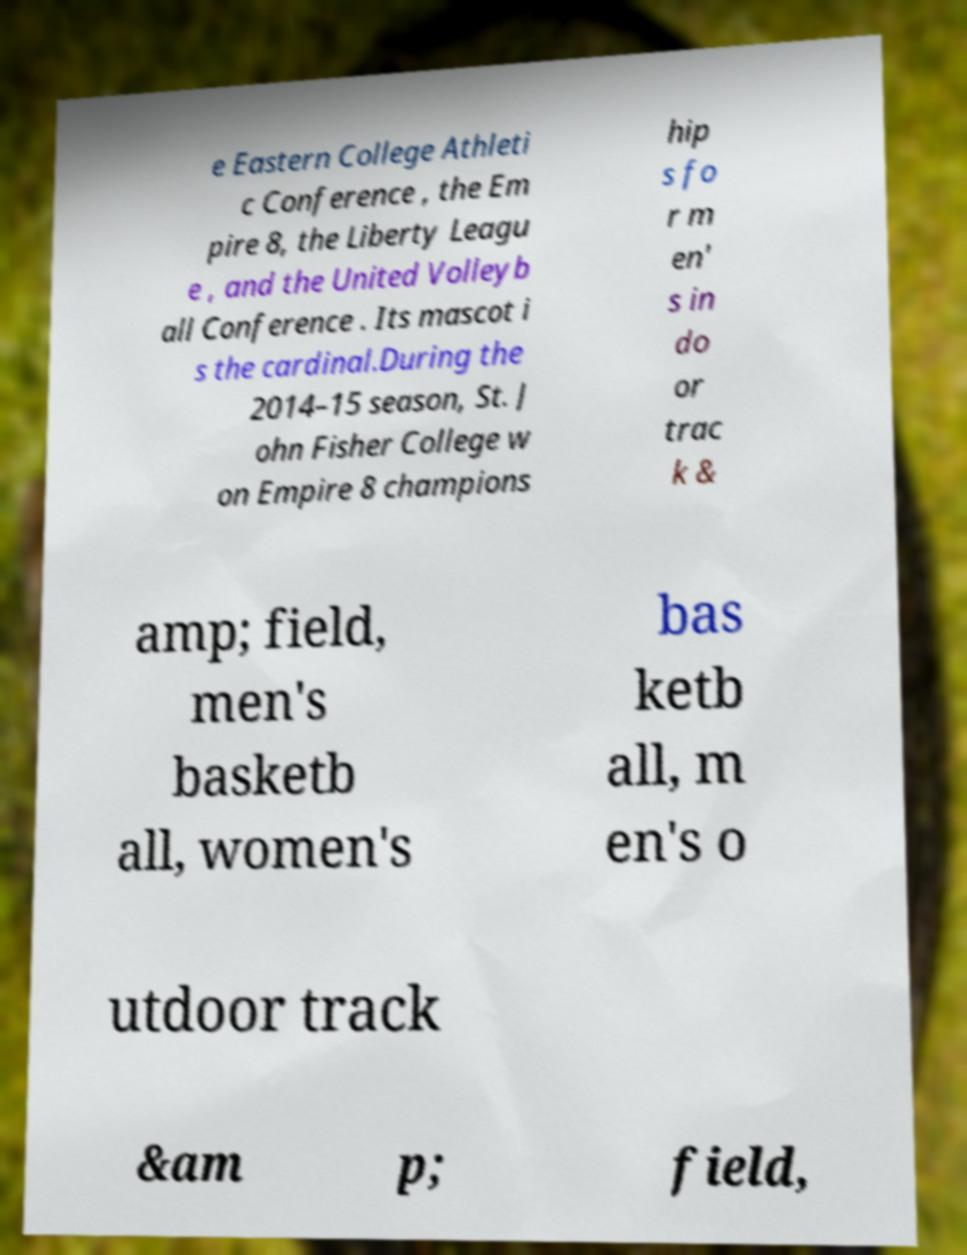Could you extract and type out the text from this image? e Eastern College Athleti c Conference , the Em pire 8, the Liberty Leagu e , and the United Volleyb all Conference . Its mascot i s the cardinal.During the 2014–15 season, St. J ohn Fisher College w on Empire 8 champions hip s fo r m en' s in do or trac k & amp; field, men's basketb all, women's bas ketb all, m en's o utdoor track &am p; field, 